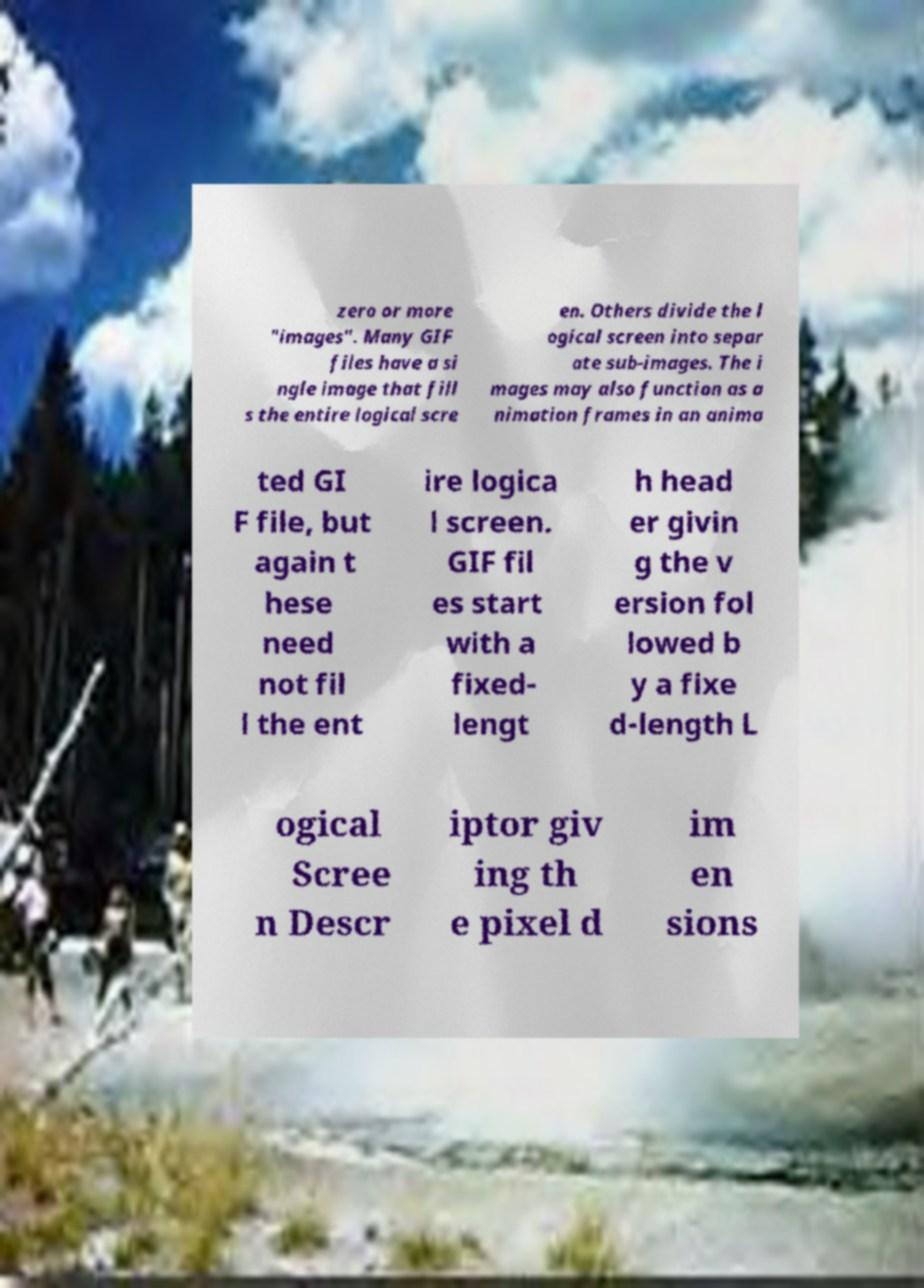Please read and relay the text visible in this image. What does it say? zero or more "images". Many GIF files have a si ngle image that fill s the entire logical scre en. Others divide the l ogical screen into separ ate sub-images. The i mages may also function as a nimation frames in an anima ted GI F file, but again t hese need not fil l the ent ire logica l screen. GIF fil es start with a fixed- lengt h head er givin g the v ersion fol lowed b y a fixe d-length L ogical Scree n Descr iptor giv ing th e pixel d im en sions 